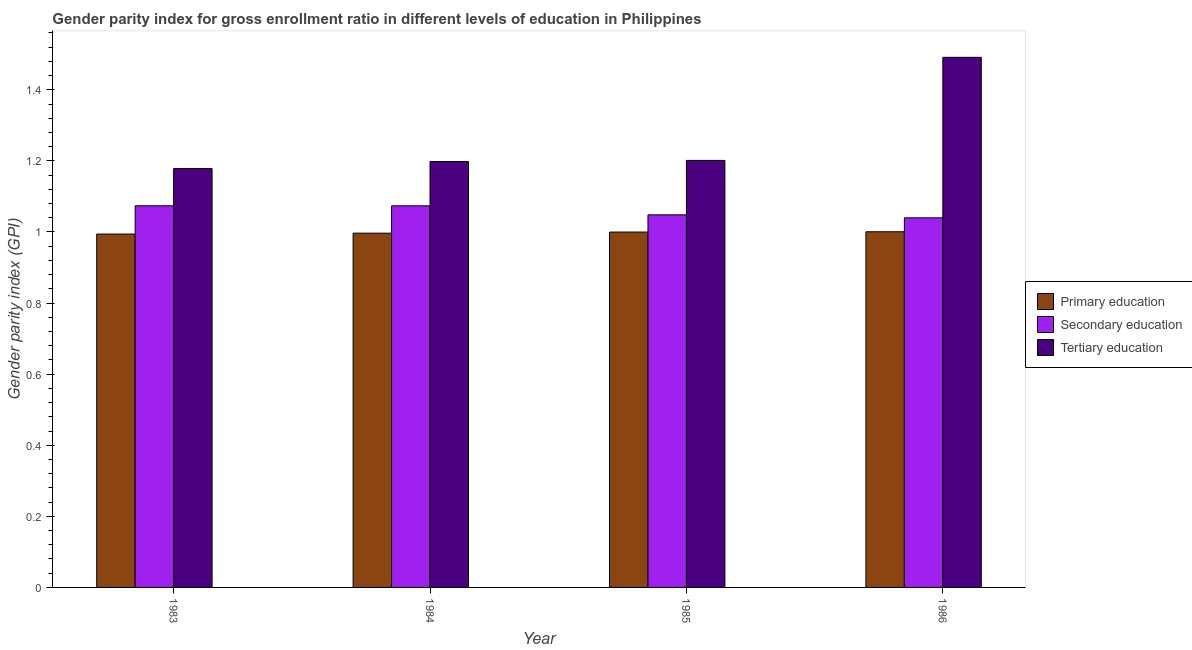How many different coloured bars are there?
Give a very brief answer. 3. How many groups of bars are there?
Provide a succinct answer. 4. Are the number of bars on each tick of the X-axis equal?
Provide a short and direct response. Yes. How many bars are there on the 3rd tick from the right?
Give a very brief answer. 3. In how many cases, is the number of bars for a given year not equal to the number of legend labels?
Provide a succinct answer. 0. What is the gender parity index in secondary education in 1985?
Your answer should be very brief. 1.05. Across all years, what is the maximum gender parity index in primary education?
Your response must be concise. 1. Across all years, what is the minimum gender parity index in tertiary education?
Your response must be concise. 1.18. In which year was the gender parity index in primary education minimum?
Give a very brief answer. 1983. What is the total gender parity index in primary education in the graph?
Offer a terse response. 3.99. What is the difference between the gender parity index in tertiary education in 1984 and that in 1986?
Make the answer very short. -0.29. What is the difference between the gender parity index in tertiary education in 1983 and the gender parity index in primary education in 1986?
Your answer should be very brief. -0.31. What is the average gender parity index in secondary education per year?
Your answer should be very brief. 1.06. In the year 1983, what is the difference between the gender parity index in secondary education and gender parity index in primary education?
Ensure brevity in your answer.  0. What is the ratio of the gender parity index in primary education in 1983 to that in 1986?
Offer a very short reply. 0.99. What is the difference between the highest and the second highest gender parity index in primary education?
Provide a succinct answer. 0. What is the difference between the highest and the lowest gender parity index in primary education?
Make the answer very short. 0.01. What does the 3rd bar from the left in 1986 represents?
Keep it short and to the point. Tertiary education. What does the 2nd bar from the right in 1985 represents?
Provide a short and direct response. Secondary education. Is it the case that in every year, the sum of the gender parity index in primary education and gender parity index in secondary education is greater than the gender parity index in tertiary education?
Make the answer very short. Yes. How many years are there in the graph?
Make the answer very short. 4. Are the values on the major ticks of Y-axis written in scientific E-notation?
Provide a short and direct response. No. Does the graph contain grids?
Make the answer very short. No. Where does the legend appear in the graph?
Keep it short and to the point. Center right. How many legend labels are there?
Your response must be concise. 3. What is the title of the graph?
Provide a short and direct response. Gender parity index for gross enrollment ratio in different levels of education in Philippines. Does "Infant(female)" appear as one of the legend labels in the graph?
Ensure brevity in your answer.  No. What is the label or title of the Y-axis?
Your answer should be compact. Gender parity index (GPI). What is the Gender parity index (GPI) in Primary education in 1983?
Your response must be concise. 0.99. What is the Gender parity index (GPI) in Secondary education in 1983?
Make the answer very short. 1.07. What is the Gender parity index (GPI) of Tertiary education in 1983?
Ensure brevity in your answer.  1.18. What is the Gender parity index (GPI) in Primary education in 1984?
Offer a very short reply. 1. What is the Gender parity index (GPI) of Secondary education in 1984?
Your answer should be very brief. 1.07. What is the Gender parity index (GPI) of Tertiary education in 1984?
Ensure brevity in your answer.  1.2. What is the Gender parity index (GPI) in Primary education in 1985?
Keep it short and to the point. 1. What is the Gender parity index (GPI) in Secondary education in 1985?
Offer a very short reply. 1.05. What is the Gender parity index (GPI) of Tertiary education in 1985?
Your answer should be compact. 1.2. What is the Gender parity index (GPI) of Primary education in 1986?
Your response must be concise. 1. What is the Gender parity index (GPI) in Secondary education in 1986?
Give a very brief answer. 1.04. What is the Gender parity index (GPI) of Tertiary education in 1986?
Keep it short and to the point. 1.49. Across all years, what is the maximum Gender parity index (GPI) in Primary education?
Your answer should be very brief. 1. Across all years, what is the maximum Gender parity index (GPI) of Secondary education?
Give a very brief answer. 1.07. Across all years, what is the maximum Gender parity index (GPI) of Tertiary education?
Offer a terse response. 1.49. Across all years, what is the minimum Gender parity index (GPI) of Primary education?
Offer a terse response. 0.99. Across all years, what is the minimum Gender parity index (GPI) in Secondary education?
Your answer should be very brief. 1.04. Across all years, what is the minimum Gender parity index (GPI) of Tertiary education?
Ensure brevity in your answer.  1.18. What is the total Gender parity index (GPI) in Primary education in the graph?
Your answer should be compact. 3.99. What is the total Gender parity index (GPI) of Secondary education in the graph?
Make the answer very short. 4.24. What is the total Gender parity index (GPI) in Tertiary education in the graph?
Give a very brief answer. 5.07. What is the difference between the Gender parity index (GPI) in Primary education in 1983 and that in 1984?
Provide a short and direct response. -0. What is the difference between the Gender parity index (GPI) in Secondary education in 1983 and that in 1984?
Provide a succinct answer. 0. What is the difference between the Gender parity index (GPI) of Tertiary education in 1983 and that in 1984?
Make the answer very short. -0.02. What is the difference between the Gender parity index (GPI) in Primary education in 1983 and that in 1985?
Your answer should be compact. -0.01. What is the difference between the Gender parity index (GPI) in Secondary education in 1983 and that in 1985?
Give a very brief answer. 0.03. What is the difference between the Gender parity index (GPI) in Tertiary education in 1983 and that in 1985?
Your answer should be very brief. -0.02. What is the difference between the Gender parity index (GPI) in Primary education in 1983 and that in 1986?
Offer a terse response. -0.01. What is the difference between the Gender parity index (GPI) of Secondary education in 1983 and that in 1986?
Ensure brevity in your answer.  0.03. What is the difference between the Gender parity index (GPI) in Tertiary education in 1983 and that in 1986?
Your response must be concise. -0.31. What is the difference between the Gender parity index (GPI) in Primary education in 1984 and that in 1985?
Ensure brevity in your answer.  -0. What is the difference between the Gender parity index (GPI) in Secondary education in 1984 and that in 1985?
Offer a terse response. 0.03. What is the difference between the Gender parity index (GPI) of Tertiary education in 1984 and that in 1985?
Give a very brief answer. -0. What is the difference between the Gender parity index (GPI) in Primary education in 1984 and that in 1986?
Ensure brevity in your answer.  -0. What is the difference between the Gender parity index (GPI) in Secondary education in 1984 and that in 1986?
Provide a succinct answer. 0.03. What is the difference between the Gender parity index (GPI) of Tertiary education in 1984 and that in 1986?
Your response must be concise. -0.29. What is the difference between the Gender parity index (GPI) of Primary education in 1985 and that in 1986?
Offer a very short reply. -0. What is the difference between the Gender parity index (GPI) of Secondary education in 1985 and that in 1986?
Ensure brevity in your answer.  0.01. What is the difference between the Gender parity index (GPI) in Tertiary education in 1985 and that in 1986?
Offer a very short reply. -0.29. What is the difference between the Gender parity index (GPI) of Primary education in 1983 and the Gender parity index (GPI) of Secondary education in 1984?
Offer a very short reply. -0.08. What is the difference between the Gender parity index (GPI) of Primary education in 1983 and the Gender parity index (GPI) of Tertiary education in 1984?
Give a very brief answer. -0.2. What is the difference between the Gender parity index (GPI) of Secondary education in 1983 and the Gender parity index (GPI) of Tertiary education in 1984?
Offer a very short reply. -0.12. What is the difference between the Gender parity index (GPI) in Primary education in 1983 and the Gender parity index (GPI) in Secondary education in 1985?
Provide a short and direct response. -0.05. What is the difference between the Gender parity index (GPI) of Primary education in 1983 and the Gender parity index (GPI) of Tertiary education in 1985?
Your response must be concise. -0.21. What is the difference between the Gender parity index (GPI) in Secondary education in 1983 and the Gender parity index (GPI) in Tertiary education in 1985?
Provide a succinct answer. -0.13. What is the difference between the Gender parity index (GPI) of Primary education in 1983 and the Gender parity index (GPI) of Secondary education in 1986?
Give a very brief answer. -0.05. What is the difference between the Gender parity index (GPI) of Primary education in 1983 and the Gender parity index (GPI) of Tertiary education in 1986?
Provide a short and direct response. -0.5. What is the difference between the Gender parity index (GPI) in Secondary education in 1983 and the Gender parity index (GPI) in Tertiary education in 1986?
Give a very brief answer. -0.42. What is the difference between the Gender parity index (GPI) of Primary education in 1984 and the Gender parity index (GPI) of Secondary education in 1985?
Give a very brief answer. -0.05. What is the difference between the Gender parity index (GPI) in Primary education in 1984 and the Gender parity index (GPI) in Tertiary education in 1985?
Your answer should be compact. -0.2. What is the difference between the Gender parity index (GPI) in Secondary education in 1984 and the Gender parity index (GPI) in Tertiary education in 1985?
Offer a very short reply. -0.13. What is the difference between the Gender parity index (GPI) of Primary education in 1984 and the Gender parity index (GPI) of Secondary education in 1986?
Your response must be concise. -0.04. What is the difference between the Gender parity index (GPI) in Primary education in 1984 and the Gender parity index (GPI) in Tertiary education in 1986?
Your answer should be compact. -0.49. What is the difference between the Gender parity index (GPI) of Secondary education in 1984 and the Gender parity index (GPI) of Tertiary education in 1986?
Your answer should be very brief. -0.42. What is the difference between the Gender parity index (GPI) of Primary education in 1985 and the Gender parity index (GPI) of Secondary education in 1986?
Your response must be concise. -0.04. What is the difference between the Gender parity index (GPI) of Primary education in 1985 and the Gender parity index (GPI) of Tertiary education in 1986?
Offer a terse response. -0.49. What is the difference between the Gender parity index (GPI) in Secondary education in 1985 and the Gender parity index (GPI) in Tertiary education in 1986?
Ensure brevity in your answer.  -0.44. What is the average Gender parity index (GPI) in Secondary education per year?
Your response must be concise. 1.06. What is the average Gender parity index (GPI) in Tertiary education per year?
Your answer should be compact. 1.27. In the year 1983, what is the difference between the Gender parity index (GPI) of Primary education and Gender parity index (GPI) of Secondary education?
Offer a terse response. -0.08. In the year 1983, what is the difference between the Gender parity index (GPI) of Primary education and Gender parity index (GPI) of Tertiary education?
Keep it short and to the point. -0.18. In the year 1983, what is the difference between the Gender parity index (GPI) in Secondary education and Gender parity index (GPI) in Tertiary education?
Your response must be concise. -0.1. In the year 1984, what is the difference between the Gender parity index (GPI) in Primary education and Gender parity index (GPI) in Secondary education?
Make the answer very short. -0.08. In the year 1984, what is the difference between the Gender parity index (GPI) of Primary education and Gender parity index (GPI) of Tertiary education?
Provide a succinct answer. -0.2. In the year 1984, what is the difference between the Gender parity index (GPI) in Secondary education and Gender parity index (GPI) in Tertiary education?
Keep it short and to the point. -0.12. In the year 1985, what is the difference between the Gender parity index (GPI) of Primary education and Gender parity index (GPI) of Secondary education?
Ensure brevity in your answer.  -0.05. In the year 1985, what is the difference between the Gender parity index (GPI) in Primary education and Gender parity index (GPI) in Tertiary education?
Keep it short and to the point. -0.2. In the year 1985, what is the difference between the Gender parity index (GPI) in Secondary education and Gender parity index (GPI) in Tertiary education?
Ensure brevity in your answer.  -0.15. In the year 1986, what is the difference between the Gender parity index (GPI) of Primary education and Gender parity index (GPI) of Secondary education?
Give a very brief answer. -0.04. In the year 1986, what is the difference between the Gender parity index (GPI) of Primary education and Gender parity index (GPI) of Tertiary education?
Ensure brevity in your answer.  -0.49. In the year 1986, what is the difference between the Gender parity index (GPI) in Secondary education and Gender parity index (GPI) in Tertiary education?
Give a very brief answer. -0.45. What is the ratio of the Gender parity index (GPI) in Primary education in 1983 to that in 1984?
Make the answer very short. 1. What is the ratio of the Gender parity index (GPI) of Tertiary education in 1983 to that in 1984?
Ensure brevity in your answer.  0.98. What is the ratio of the Gender parity index (GPI) in Secondary education in 1983 to that in 1985?
Your response must be concise. 1.02. What is the ratio of the Gender parity index (GPI) of Tertiary education in 1983 to that in 1985?
Keep it short and to the point. 0.98. What is the ratio of the Gender parity index (GPI) of Secondary education in 1983 to that in 1986?
Your answer should be very brief. 1.03. What is the ratio of the Gender parity index (GPI) of Tertiary education in 1983 to that in 1986?
Provide a succinct answer. 0.79. What is the ratio of the Gender parity index (GPI) of Secondary education in 1984 to that in 1985?
Provide a succinct answer. 1.02. What is the ratio of the Gender parity index (GPI) of Tertiary education in 1984 to that in 1985?
Keep it short and to the point. 1. What is the ratio of the Gender parity index (GPI) in Primary education in 1984 to that in 1986?
Your answer should be compact. 1. What is the ratio of the Gender parity index (GPI) of Secondary education in 1984 to that in 1986?
Provide a short and direct response. 1.03. What is the ratio of the Gender parity index (GPI) in Tertiary education in 1984 to that in 1986?
Provide a short and direct response. 0.8. What is the ratio of the Gender parity index (GPI) in Primary education in 1985 to that in 1986?
Make the answer very short. 1. What is the ratio of the Gender parity index (GPI) in Tertiary education in 1985 to that in 1986?
Make the answer very short. 0.81. What is the difference between the highest and the second highest Gender parity index (GPI) of Primary education?
Provide a short and direct response. 0. What is the difference between the highest and the second highest Gender parity index (GPI) in Secondary education?
Ensure brevity in your answer.  0. What is the difference between the highest and the second highest Gender parity index (GPI) in Tertiary education?
Make the answer very short. 0.29. What is the difference between the highest and the lowest Gender parity index (GPI) of Primary education?
Give a very brief answer. 0.01. What is the difference between the highest and the lowest Gender parity index (GPI) of Secondary education?
Ensure brevity in your answer.  0.03. What is the difference between the highest and the lowest Gender parity index (GPI) in Tertiary education?
Ensure brevity in your answer.  0.31. 